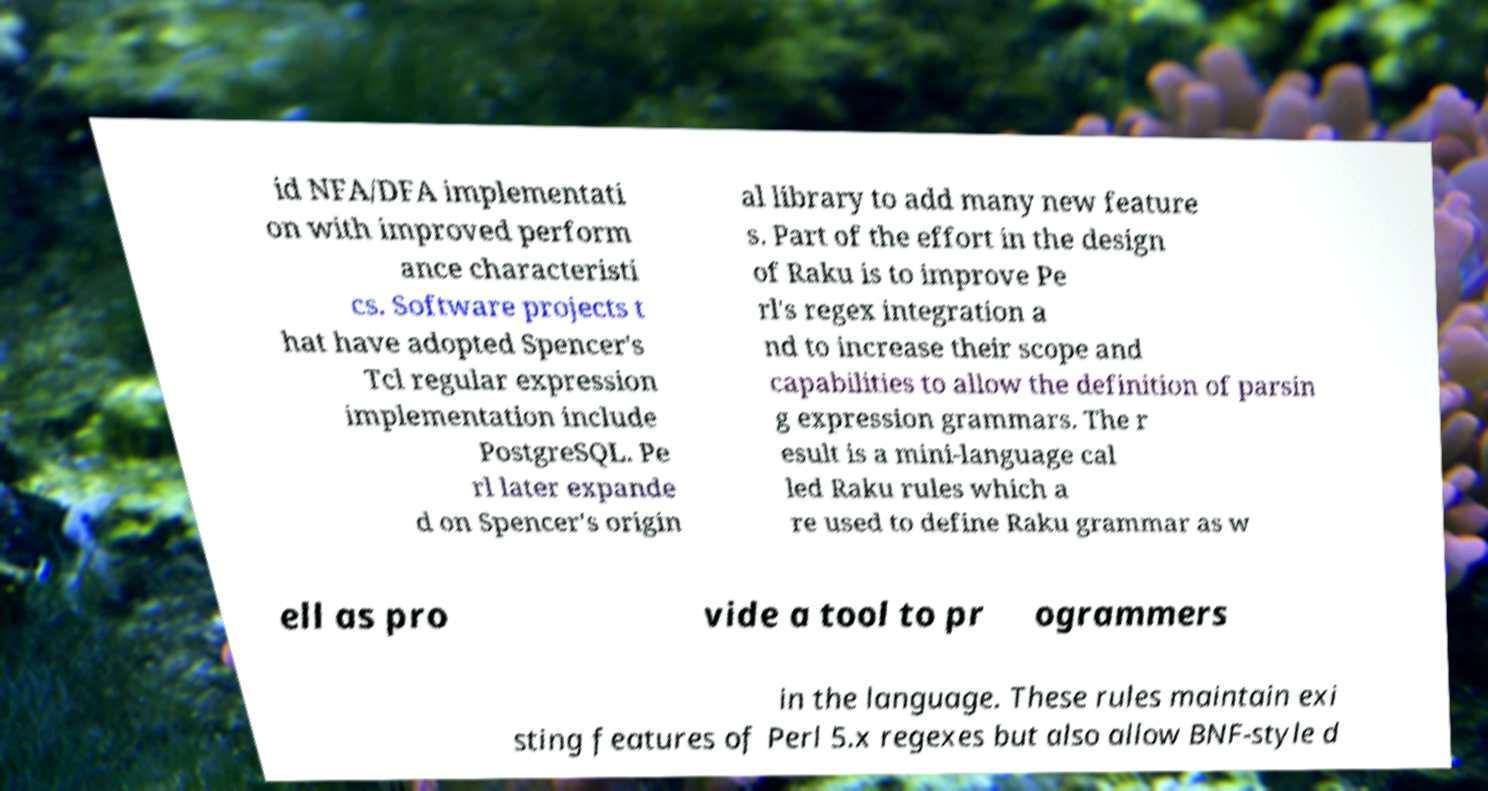There's text embedded in this image that I need extracted. Can you transcribe it verbatim? id NFA/DFA implementati on with improved perform ance characteristi cs. Software projects t hat have adopted Spencer's Tcl regular expression implementation include PostgreSQL. Pe rl later expande d on Spencer's origin al library to add many new feature s. Part of the effort in the design of Raku is to improve Pe rl's regex integration a nd to increase their scope and capabilities to allow the definition of parsin g expression grammars. The r esult is a mini-language cal led Raku rules which a re used to define Raku grammar as w ell as pro vide a tool to pr ogrammers in the language. These rules maintain exi sting features of Perl 5.x regexes but also allow BNF-style d 